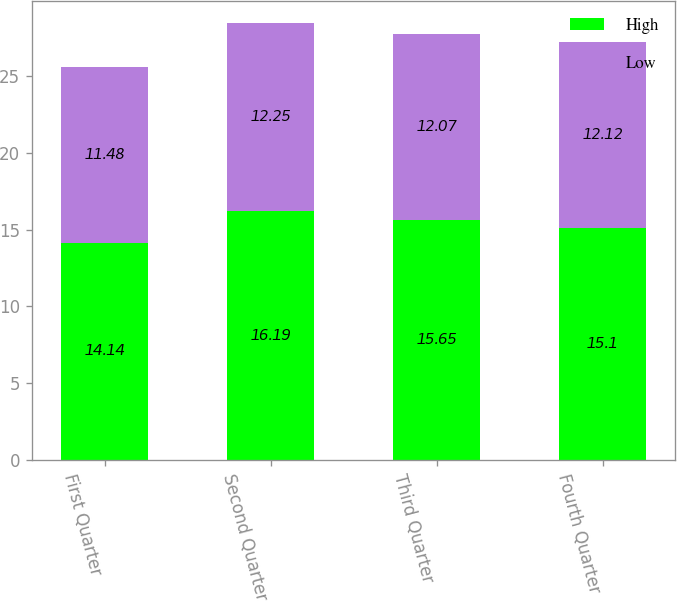Convert chart. <chart><loc_0><loc_0><loc_500><loc_500><stacked_bar_chart><ecel><fcel>First Quarter<fcel>Second Quarter<fcel>Third Quarter<fcel>Fourth Quarter<nl><fcel>High<fcel>14.14<fcel>16.19<fcel>15.65<fcel>15.1<nl><fcel>Low<fcel>11.48<fcel>12.25<fcel>12.07<fcel>12.12<nl></chart> 